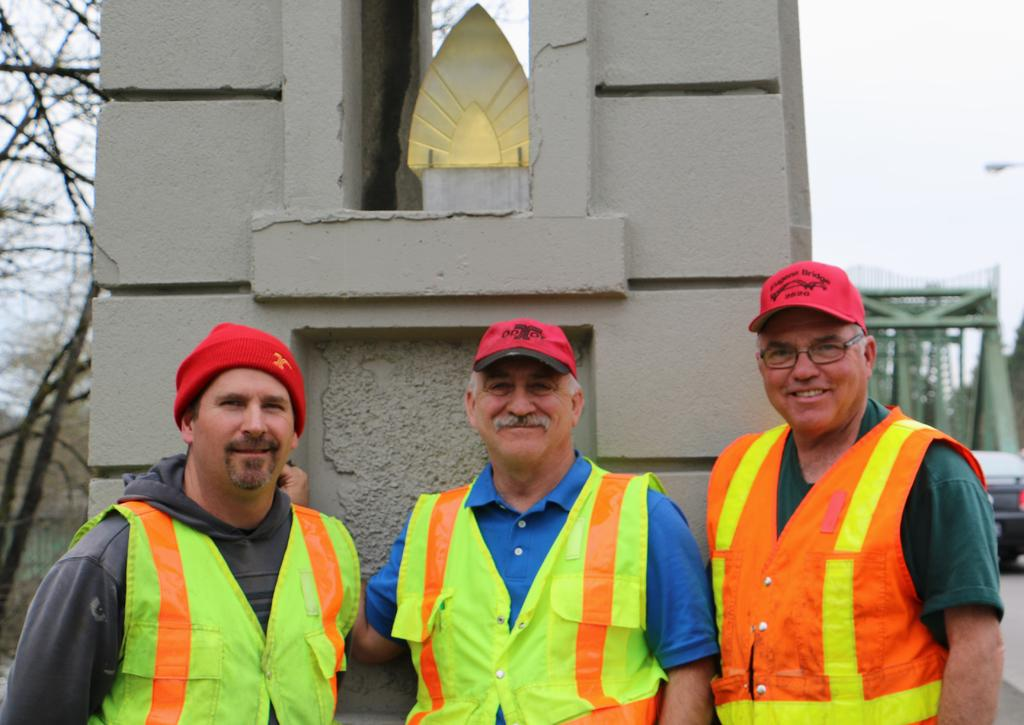How many people are in the image? There are three people in the image. What are the people doing in the image? The people are watching and smiling. What are the people wearing in the image? The people are wearing caps and jackets. What can be seen in the background of the image? There are pillars, trees, a vehicle, rods, a road, and the sky visible in the background of the image. What activity is the grandmother participating in with the people in the image? There is no grandmother present in the image, and the people are not participating in any specific activity. Can you see a robin in the image? There is no robin present in the image. 